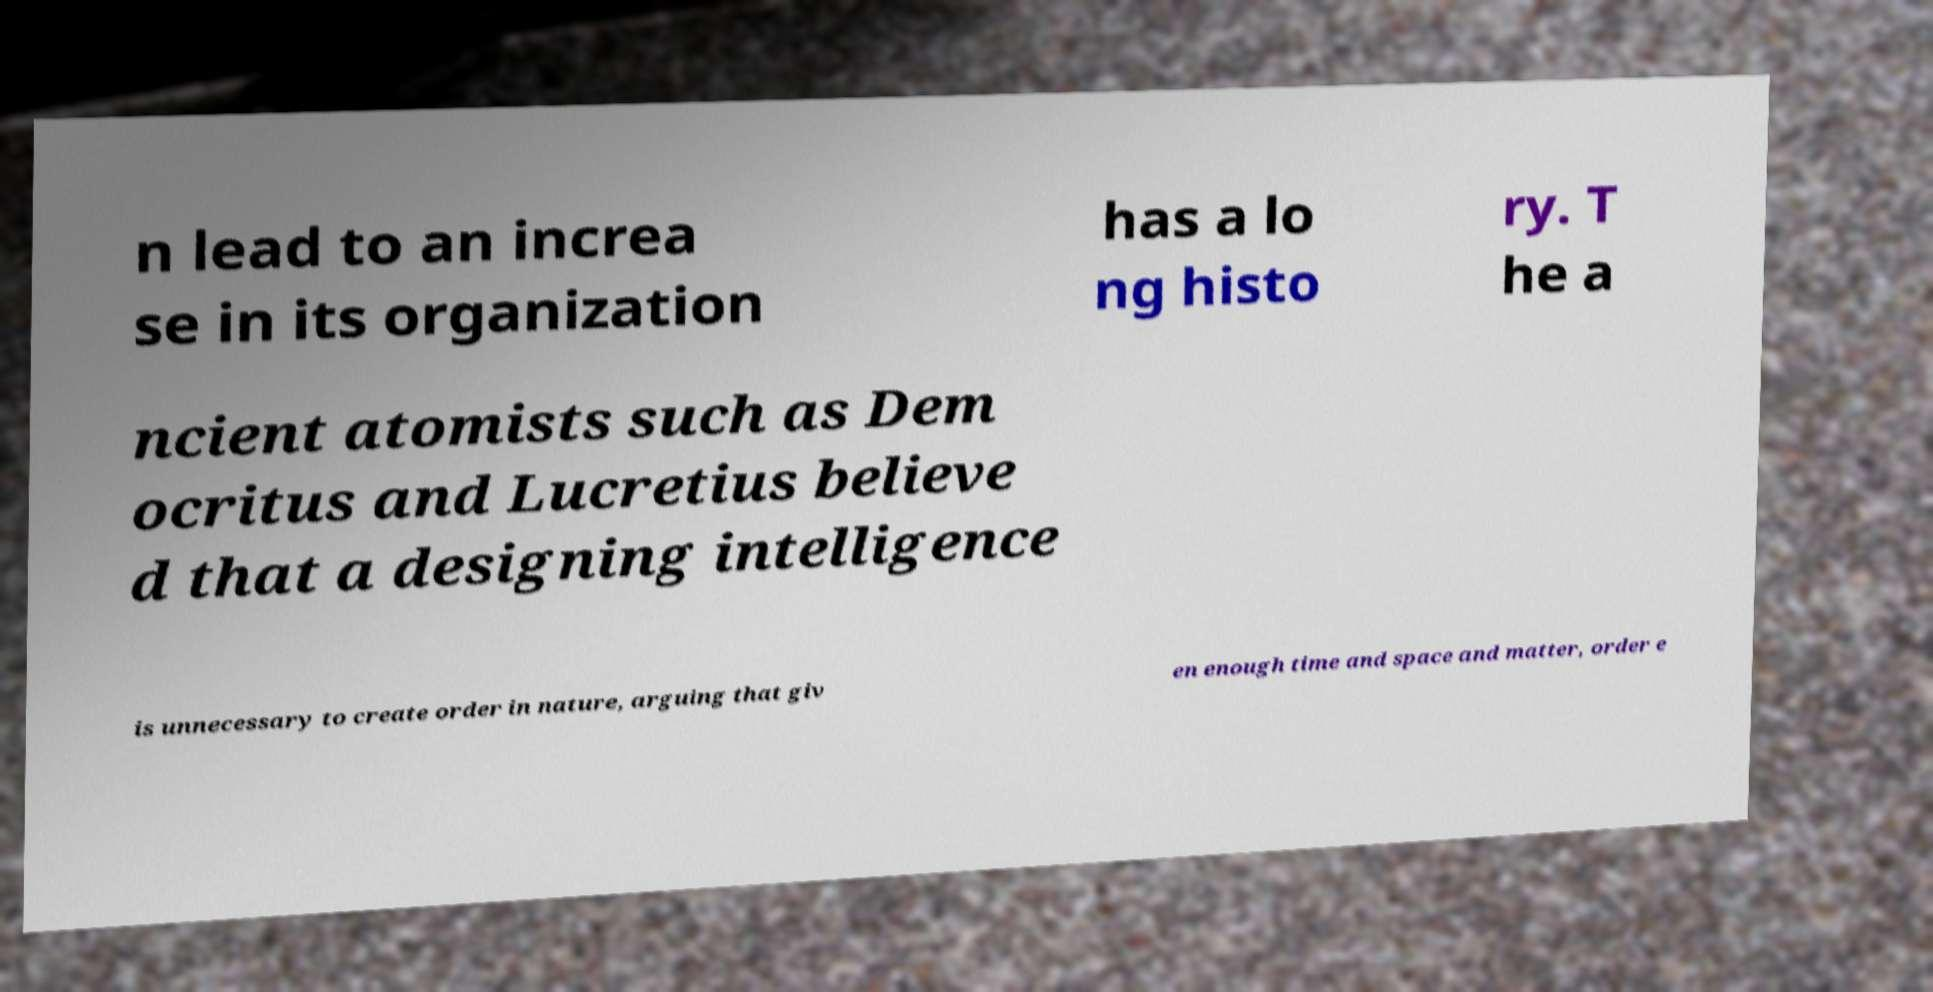Please identify and transcribe the text found in this image. n lead to an increa se in its organization has a lo ng histo ry. T he a ncient atomists such as Dem ocritus and Lucretius believe d that a designing intelligence is unnecessary to create order in nature, arguing that giv en enough time and space and matter, order e 